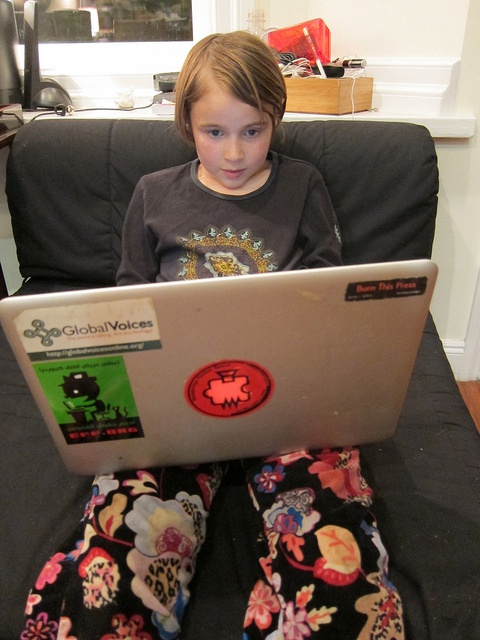Describe the objects in this image and their specific colors. I can see couch in gray and black tones, laptop in gray and black tones, chair in gray and black tones, and people in gray and black tones in this image. 